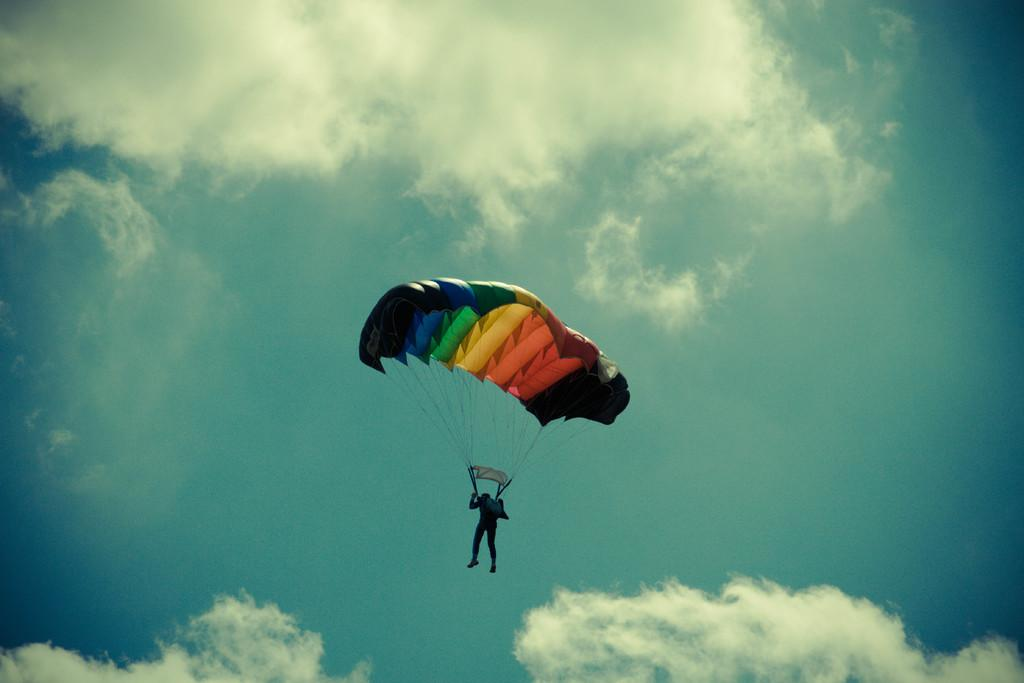What is happening to the person in the image? The person is flying in the air. How is the person able to fly in the image? The person has a parachute, which allows them to fly. What is visible in the background of the image? There is a sky visible in the image, with clouds present. What type of current is affecting the person's health in the image? There is no reference to a current or any health concerns in the image, so it's not possible to determine what, if any, current might be affecting the person's health. 